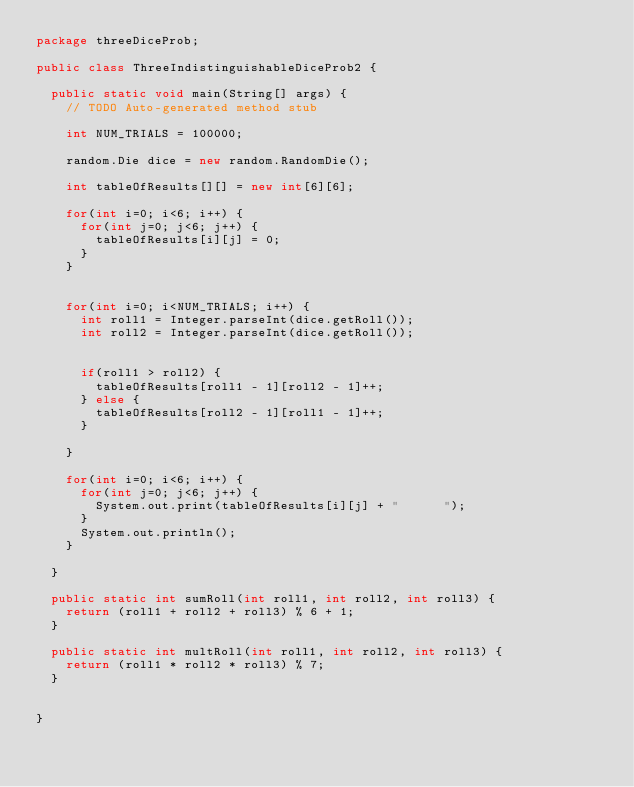Convert code to text. <code><loc_0><loc_0><loc_500><loc_500><_Java_>package threeDiceProb;

public class ThreeIndistinguishableDiceProb2 {

	public static void main(String[] args) {
		// TODO Auto-generated method stub
		
		int NUM_TRIALS = 100000;
		
		random.Die dice = new random.RandomDie();
		
		int tableOfResults[][] = new int[6][6];

		for(int i=0; i<6; i++) {
			for(int j=0; j<6; j++) {
				tableOfResults[i][j] = 0;
			}
		}
		
		
		for(int i=0; i<NUM_TRIALS; i++) {
			int roll1 = Integer.parseInt(dice.getRoll());
			int roll2 = Integer.parseInt(dice.getRoll());
					
			
			if(roll1 > roll2) {
				tableOfResults[roll1 - 1][roll2 - 1]++;
			} else {
				tableOfResults[roll2 - 1][roll1 - 1]++;
			}
			
		}
		
		for(int i=0; i<6; i++) {
			for(int j=0; j<6; j++) {
				System.out.print(tableOfResults[i][j] + "      ");
			}
			System.out.println();
		}
		
	}
	
	public static int sumRoll(int roll1, int roll2, int roll3) {
		return (roll1 + roll2 + roll3) % 6 + 1;
	}
	
	public static int multRoll(int roll1, int roll2, int roll3) {
		return (roll1 * roll2 * roll3) % 7;
	}
	

}
</code> 